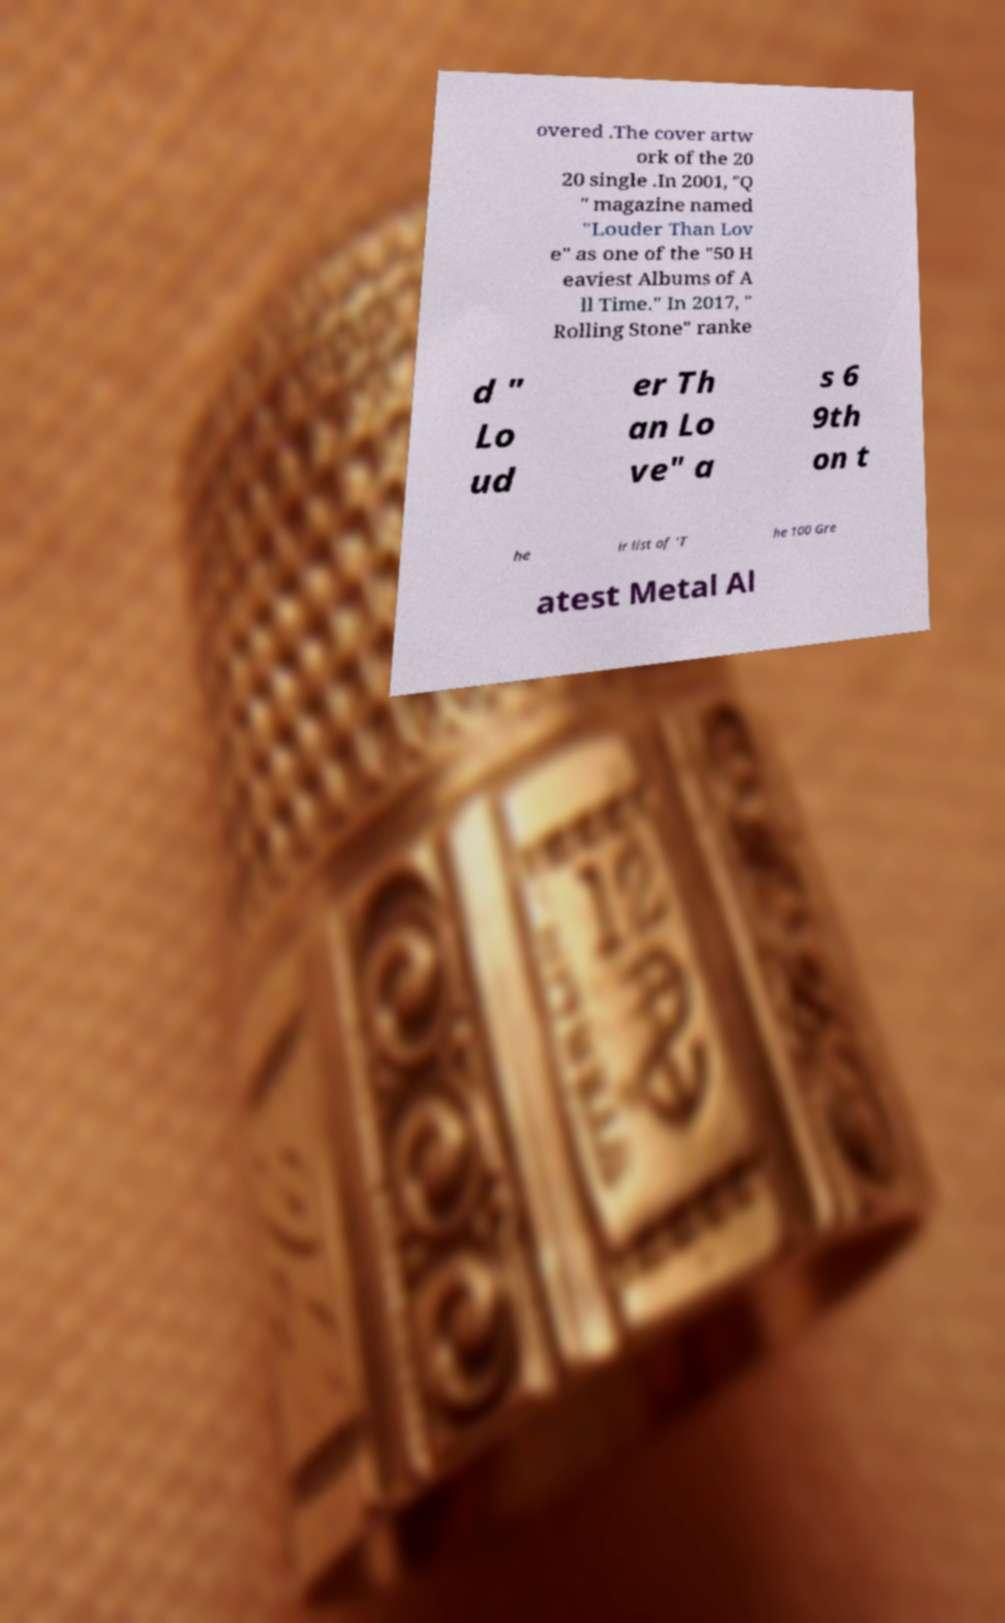What messages or text are displayed in this image? I need them in a readable, typed format. overed .The cover artw ork of the 20 20 single .In 2001, "Q " magazine named "Louder Than Lov e" as one of the "50 H eaviest Albums of A ll Time." In 2017, " Rolling Stone" ranke d " Lo ud er Th an Lo ve" a s 6 9th on t he ir list of 'T he 100 Gre atest Metal Al 